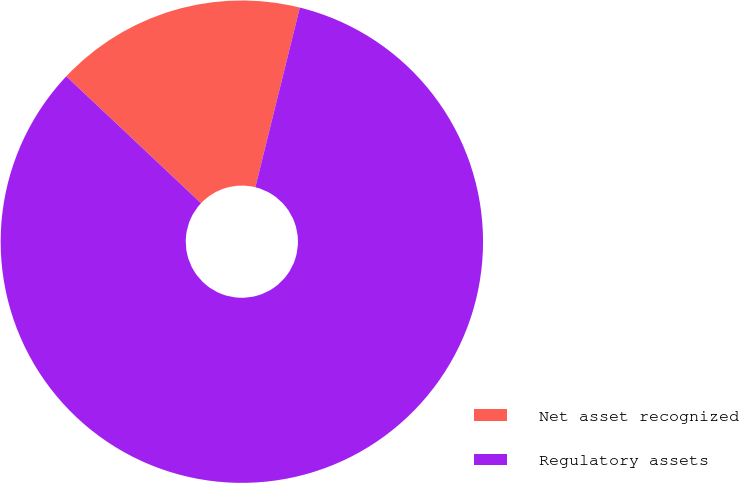<chart> <loc_0><loc_0><loc_500><loc_500><pie_chart><fcel>Net asset recognized<fcel>Regulatory assets<nl><fcel>16.84%<fcel>83.16%<nl></chart> 